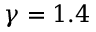<formula> <loc_0><loc_0><loc_500><loc_500>\gamma = 1 . 4</formula> 